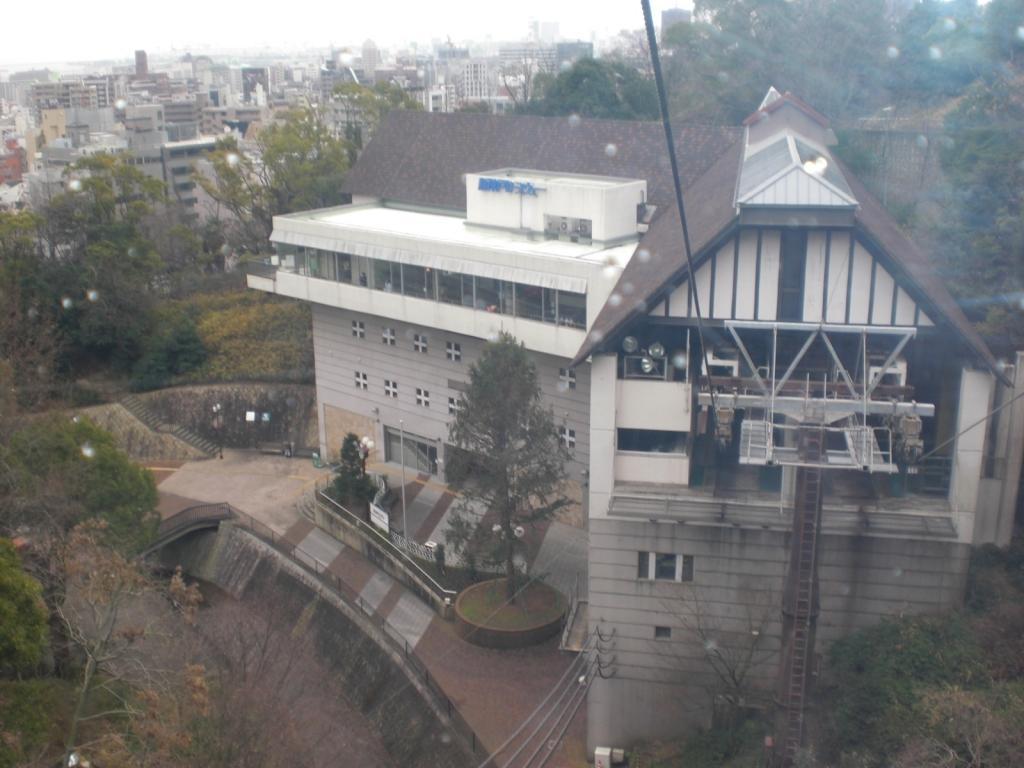Could you give a brief overview of what you see in this image? In this picture we can see some buildings and trees, there are some wires and a pole at the bottom, we can see the sky at the top of the picture. 